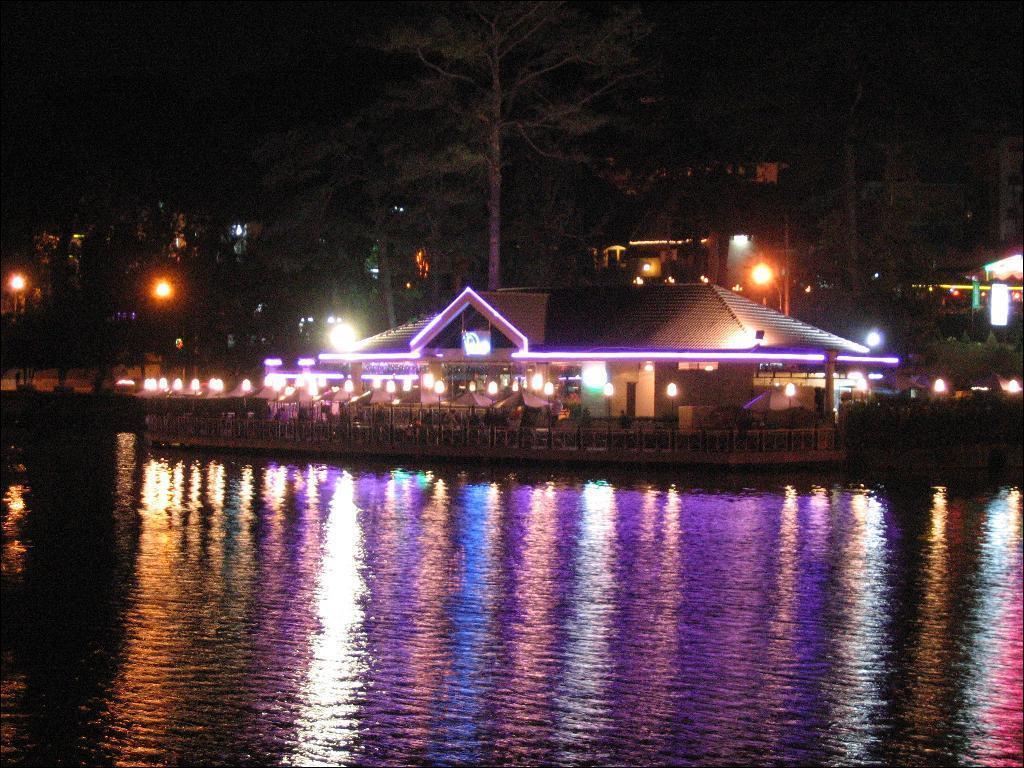Describe this image in one or two sentences. In this image we can see houses and lights. And we can see plants, trees, at the bottom we can see water, we can see dark background. 